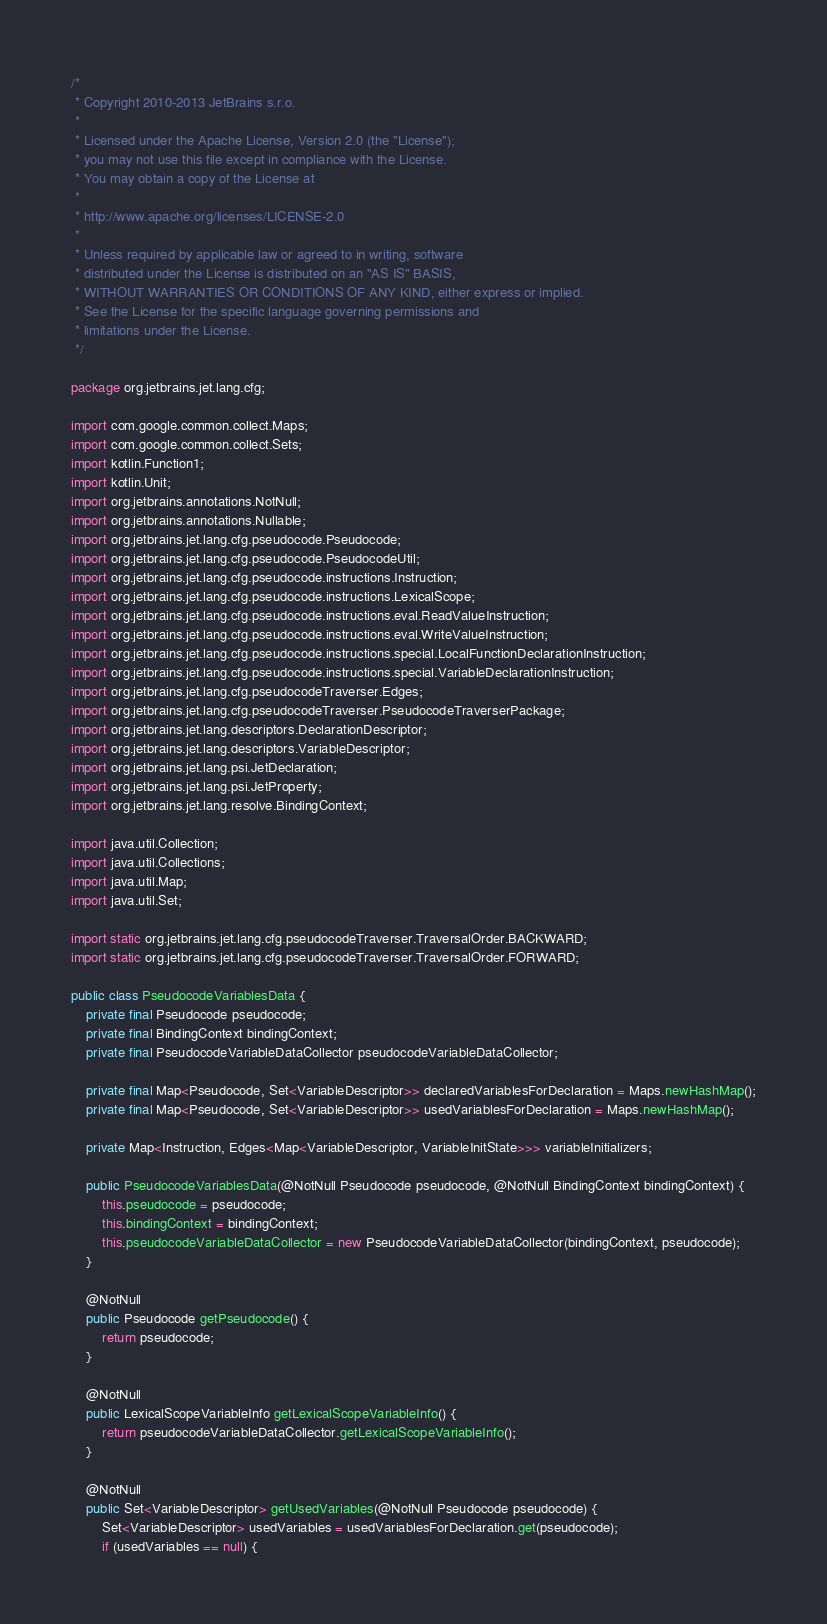Convert code to text. <code><loc_0><loc_0><loc_500><loc_500><_Java_>/*
 * Copyright 2010-2013 JetBrains s.r.o.
 *
 * Licensed under the Apache License, Version 2.0 (the "License");
 * you may not use this file except in compliance with the License.
 * You may obtain a copy of the License at
 *
 * http://www.apache.org/licenses/LICENSE-2.0
 *
 * Unless required by applicable law or agreed to in writing, software
 * distributed under the License is distributed on an "AS IS" BASIS,
 * WITHOUT WARRANTIES OR CONDITIONS OF ANY KIND, either express or implied.
 * See the License for the specific language governing permissions and
 * limitations under the License.
 */

package org.jetbrains.jet.lang.cfg;

import com.google.common.collect.Maps;
import com.google.common.collect.Sets;
import kotlin.Function1;
import kotlin.Unit;
import org.jetbrains.annotations.NotNull;
import org.jetbrains.annotations.Nullable;
import org.jetbrains.jet.lang.cfg.pseudocode.Pseudocode;
import org.jetbrains.jet.lang.cfg.pseudocode.PseudocodeUtil;
import org.jetbrains.jet.lang.cfg.pseudocode.instructions.Instruction;
import org.jetbrains.jet.lang.cfg.pseudocode.instructions.LexicalScope;
import org.jetbrains.jet.lang.cfg.pseudocode.instructions.eval.ReadValueInstruction;
import org.jetbrains.jet.lang.cfg.pseudocode.instructions.eval.WriteValueInstruction;
import org.jetbrains.jet.lang.cfg.pseudocode.instructions.special.LocalFunctionDeclarationInstruction;
import org.jetbrains.jet.lang.cfg.pseudocode.instructions.special.VariableDeclarationInstruction;
import org.jetbrains.jet.lang.cfg.pseudocodeTraverser.Edges;
import org.jetbrains.jet.lang.cfg.pseudocodeTraverser.PseudocodeTraverserPackage;
import org.jetbrains.jet.lang.descriptors.DeclarationDescriptor;
import org.jetbrains.jet.lang.descriptors.VariableDescriptor;
import org.jetbrains.jet.lang.psi.JetDeclaration;
import org.jetbrains.jet.lang.psi.JetProperty;
import org.jetbrains.jet.lang.resolve.BindingContext;

import java.util.Collection;
import java.util.Collections;
import java.util.Map;
import java.util.Set;

import static org.jetbrains.jet.lang.cfg.pseudocodeTraverser.TraversalOrder.BACKWARD;
import static org.jetbrains.jet.lang.cfg.pseudocodeTraverser.TraversalOrder.FORWARD;

public class PseudocodeVariablesData {
    private final Pseudocode pseudocode;
    private final BindingContext bindingContext;
    private final PseudocodeVariableDataCollector pseudocodeVariableDataCollector;

    private final Map<Pseudocode, Set<VariableDescriptor>> declaredVariablesForDeclaration = Maps.newHashMap();
    private final Map<Pseudocode, Set<VariableDescriptor>> usedVariablesForDeclaration = Maps.newHashMap();

    private Map<Instruction, Edges<Map<VariableDescriptor, VariableInitState>>> variableInitializers;

    public PseudocodeVariablesData(@NotNull Pseudocode pseudocode, @NotNull BindingContext bindingContext) {
        this.pseudocode = pseudocode;
        this.bindingContext = bindingContext;
        this.pseudocodeVariableDataCollector = new PseudocodeVariableDataCollector(bindingContext, pseudocode);
    }

    @NotNull
    public Pseudocode getPseudocode() {
        return pseudocode;
    }

    @NotNull
    public LexicalScopeVariableInfo getLexicalScopeVariableInfo() {
        return pseudocodeVariableDataCollector.getLexicalScopeVariableInfo();
    }

    @NotNull
    public Set<VariableDescriptor> getUsedVariables(@NotNull Pseudocode pseudocode) {
        Set<VariableDescriptor> usedVariables = usedVariablesForDeclaration.get(pseudocode);
        if (usedVariables == null) {</code> 